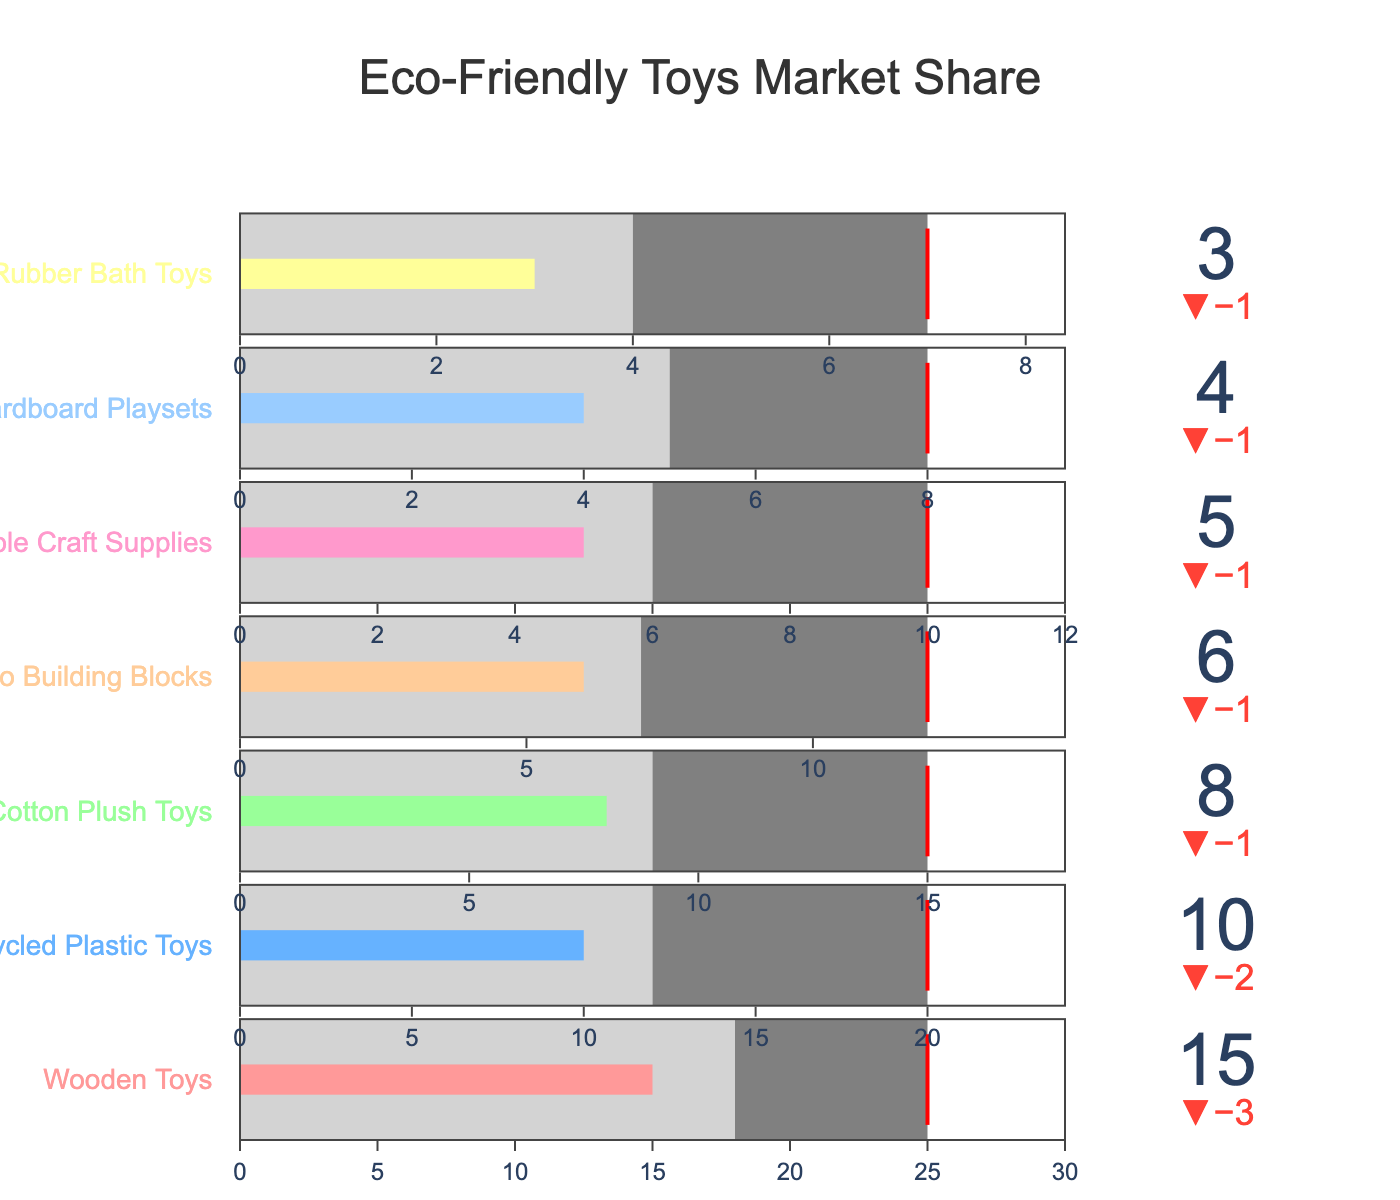What is the title of the chart? The title of the chart is displayed at the top and reads "Eco-Friendly Toys Market Share".
Answer: Eco-Friendly Toys Market Share Which category has the highest current market share? Among the categories, "Wooden Toys" has the highest current market share as represented by the corresponding bar, which shows a value of 15.
Answer: Wooden Toys What is the industry average for Recycled Plastic Toys? The industry average for each category is marked on the chart, and for Recycled Plastic Toys, it is indicated at a value of 12.
Answer: 12 What is the target market share for Bamboo Building Blocks? The target market share is marked by a red threshold line for each category. For Bamboo Building Blocks, this value is 12.
Answer: 12 By how much does the current market share of Natural Rubber Bath Toys fall short of its target? The current market share for Natural Rubber Bath Toys is 3 and the target is 7. The shortfall is calculated as 7 - 3 = 4.
Answer: 4 How do the current market shares of Organic Cotton Plush Toys and Cardboard Playsets compare? The current market share for Organic Cotton Plush Toys is 8, while Cardboard Playsets is 4. Therefore, Organic Cotton Plush Toys have a higher market share than Cardboard Playsets.
Answer: Organic Cotton Plush Toys > Cardboard Playsets Which category's current market share is closest to the industry average? By examining each category, the Wooden Toys' current market share of 15 is closest to its industry average of 18.
Answer: Wooden Toys Are any categories currently exceeding their target market share? The current market share for each category is compared to the red threshold line representing the target. None of the categories exceed their target market share.
Answer: No What is the combined current market share of Bamboo Building Blocks and Natural Rubber Bath Toys? Add the current market shares for Bamboo Building Blocks (6) and Natural Rubber Bath Toys (3). The total is 6 + 3 = 9.
Answer: 9 Which category has the smallest difference between the current market share and the industry average? By comparing the differences, the category with the smallest difference is Organic Cotton Plush Toys, with a difference of 8 - 9 = -1 or an absolute difference of 1.
Answer: Organic Cotton Plush Toys 